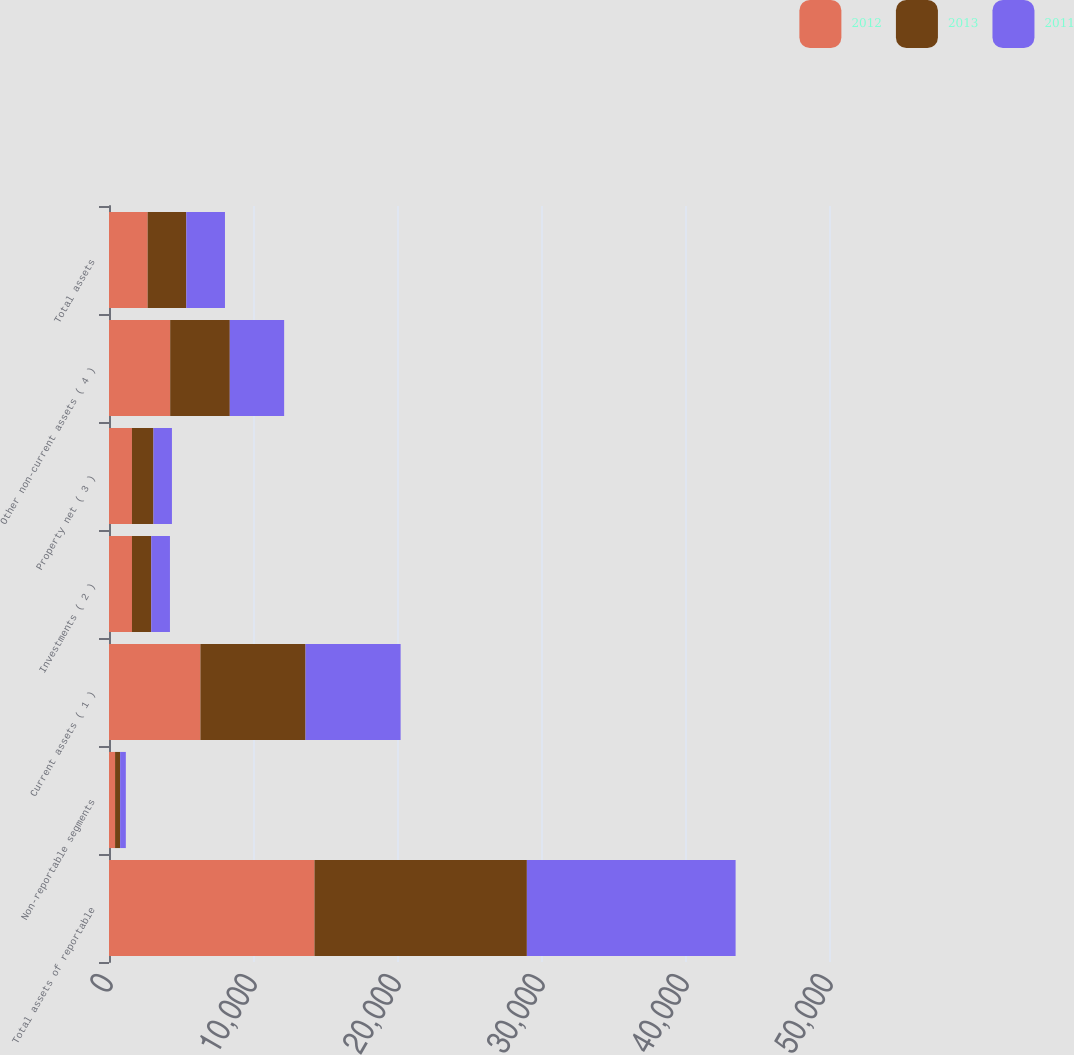Convert chart to OTSL. <chart><loc_0><loc_0><loc_500><loc_500><stacked_bar_chart><ecel><fcel>Total assets of reportable<fcel>Non-reportable segments<fcel>Current assets ( 1 )<fcel>Investments ( 2 )<fcel>Property net ( 3 )<fcel>Other non-current assets ( 4 )<fcel>Total assets<nl><fcel>2012<fcel>14269<fcel>422<fcel>6349<fcel>1595<fcel>1594<fcel>4249<fcel>2684.5<nl><fcel>2013<fcel>14750<fcel>351<fcel>7300<fcel>1340<fcel>1494<fcel>4140<fcel>2684.5<nl><fcel>2011<fcel>14495<fcel>396<fcel>6602<fcel>1298<fcel>1283<fcel>3774<fcel>2684.5<nl></chart> 